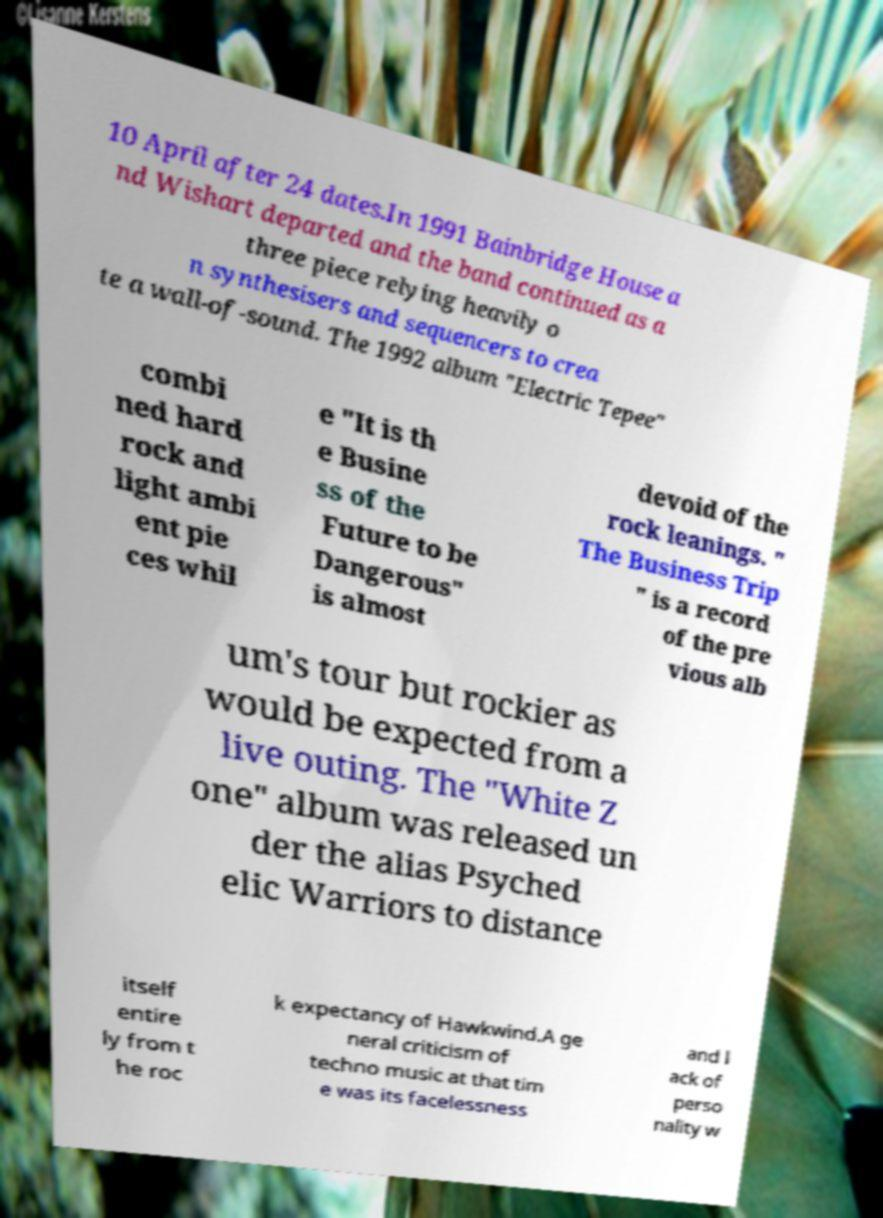What messages or text are displayed in this image? I need them in a readable, typed format. 10 April after 24 dates.In 1991 Bainbridge House a nd Wishart departed and the band continued as a three piece relying heavily o n synthesisers and sequencers to crea te a wall-of-sound. The 1992 album "Electric Tepee" combi ned hard rock and light ambi ent pie ces whil e "It is th e Busine ss of the Future to be Dangerous" is almost devoid of the rock leanings. " The Business Trip " is a record of the pre vious alb um's tour but rockier as would be expected from a live outing. The "White Z one" album was released un der the alias Psyched elic Warriors to distance itself entire ly from t he roc k expectancy of Hawkwind.A ge neral criticism of techno music at that tim e was its facelessness and l ack of perso nality w 